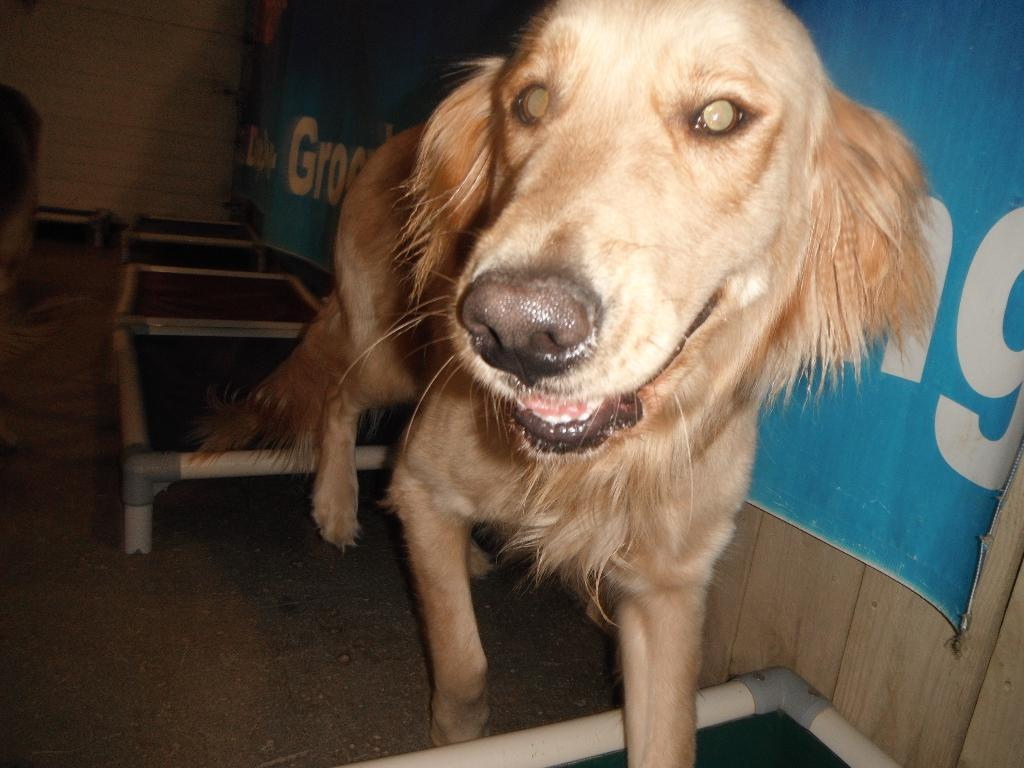What type of animal can be seen in the image? There is a dog in the image. What is the surface beneath the dog? There is ground visible in the image. What else can be found on the ground in the image? There are objects on the ground. What is the background feature in the image? There is a wall in the image. What is written on the poster in the image? There is a poster with text in the image. How does the dog compare to a cat in terms of learning abilities in the image? The image does not provide any information about the dog's learning abilities or a comparison to a cat. 